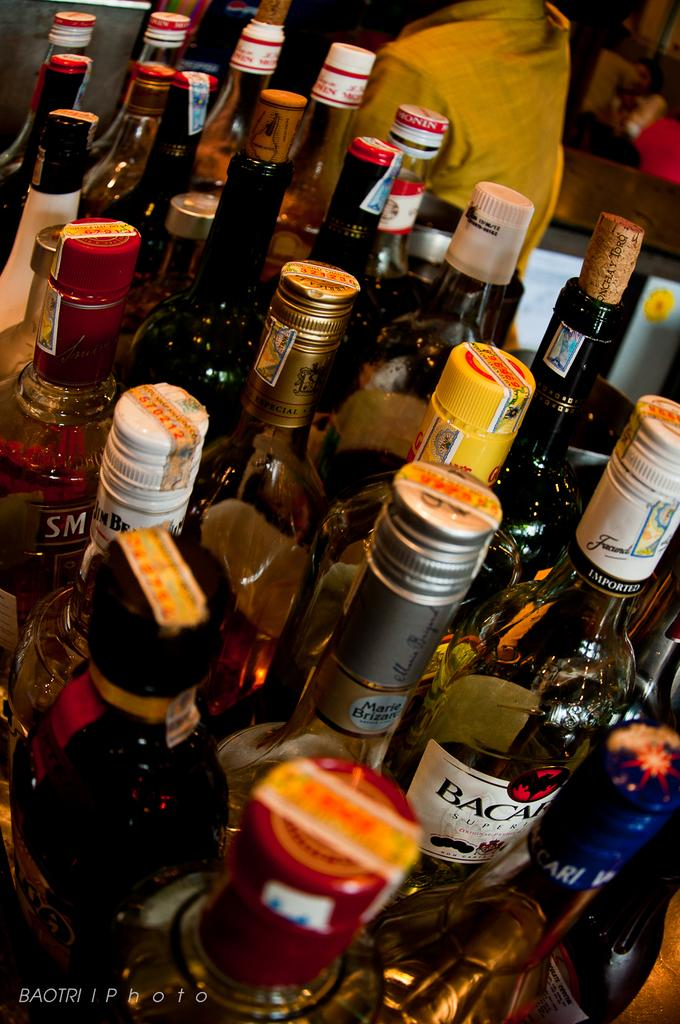<image>
Write a terse but informative summary of the picture. A collection of liquor bottles includes Bacardi and Jim Beam. 